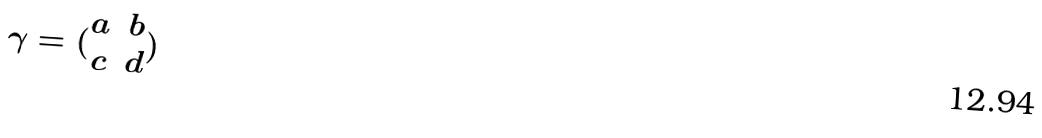<formula> <loc_0><loc_0><loc_500><loc_500>\gamma = ( \begin{matrix} a & b \\ c & d \end{matrix} )</formula> 